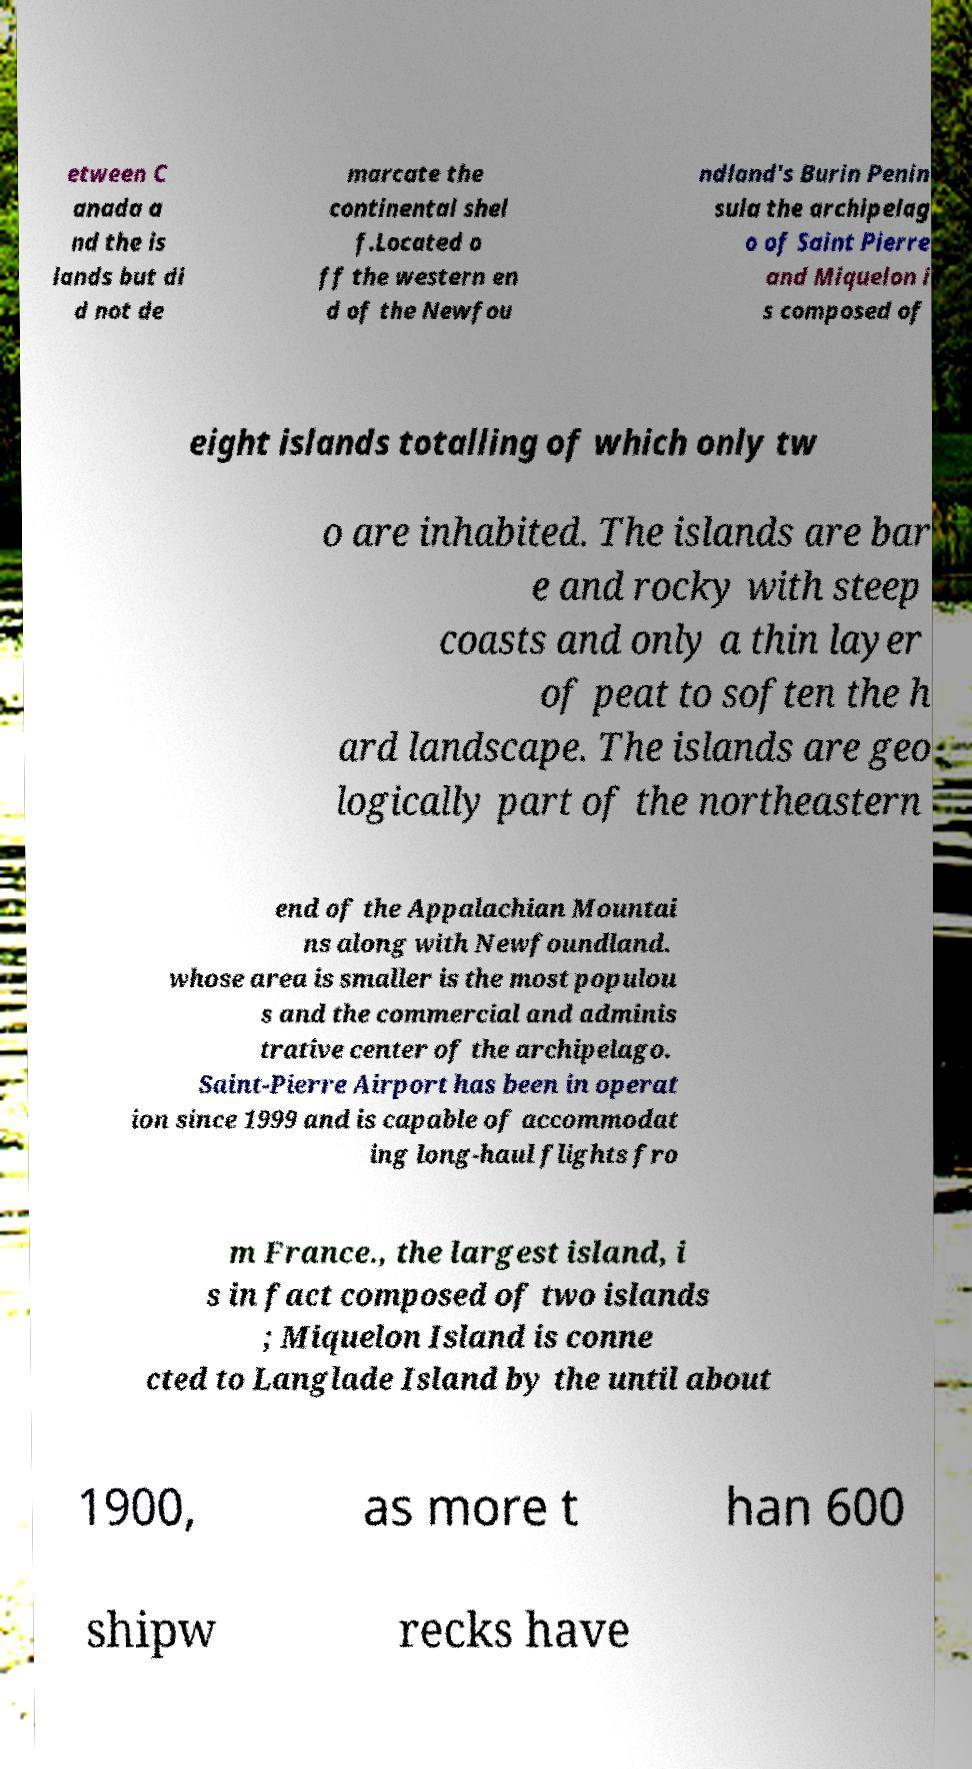Could you extract and type out the text from this image? etween C anada a nd the is lands but di d not de marcate the continental shel f.Located o ff the western en d of the Newfou ndland's Burin Penin sula the archipelag o of Saint Pierre and Miquelon i s composed of eight islands totalling of which only tw o are inhabited. The islands are bar e and rocky with steep coasts and only a thin layer of peat to soften the h ard landscape. The islands are geo logically part of the northeastern end of the Appalachian Mountai ns along with Newfoundland. whose area is smaller is the most populou s and the commercial and adminis trative center of the archipelago. Saint-Pierre Airport has been in operat ion since 1999 and is capable of accommodat ing long-haul flights fro m France., the largest island, i s in fact composed of two islands ; Miquelon Island is conne cted to Langlade Island by the until about 1900, as more t han 600 shipw recks have 